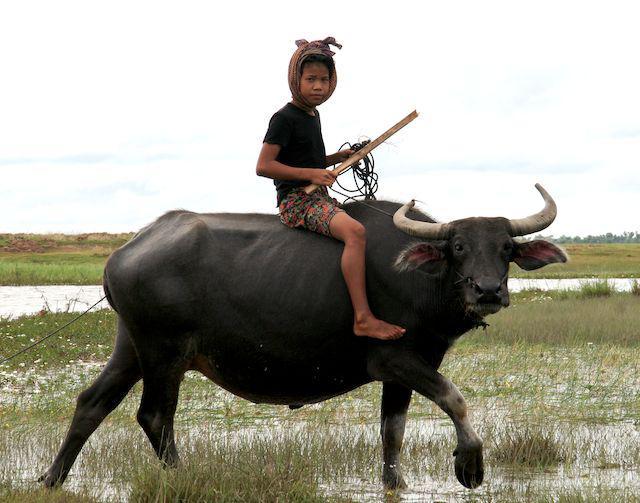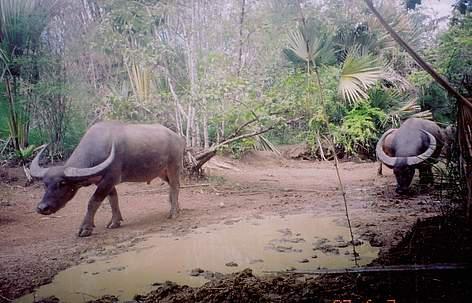The first image is the image on the left, the second image is the image on the right. Considering the images on both sides, is "A young person wearing head covering is sitting astride a horned animal." valid? Answer yes or no. Yes. The first image is the image on the left, the second image is the image on the right. Examine the images to the left and right. Is the description "One of the pictures shows a boy riding a water buffalo, and the other shows two water buffalo together." accurate? Answer yes or no. Yes. 